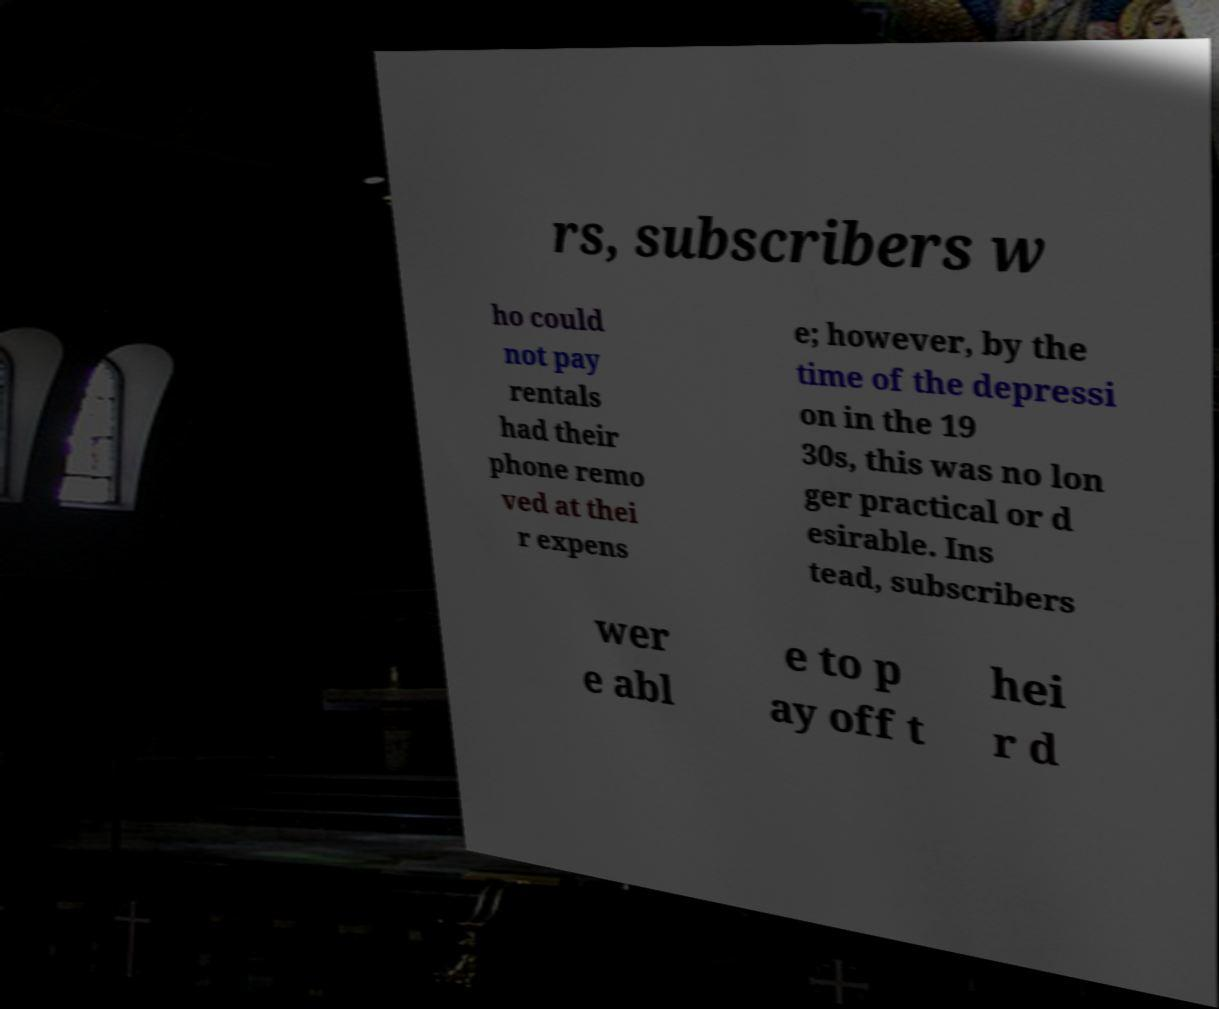I need the written content from this picture converted into text. Can you do that? rs, subscribers w ho could not pay rentals had their phone remo ved at thei r expens e; however, by the time of the depressi on in the 19 30s, this was no lon ger practical or d esirable. Ins tead, subscribers wer e abl e to p ay off t hei r d 